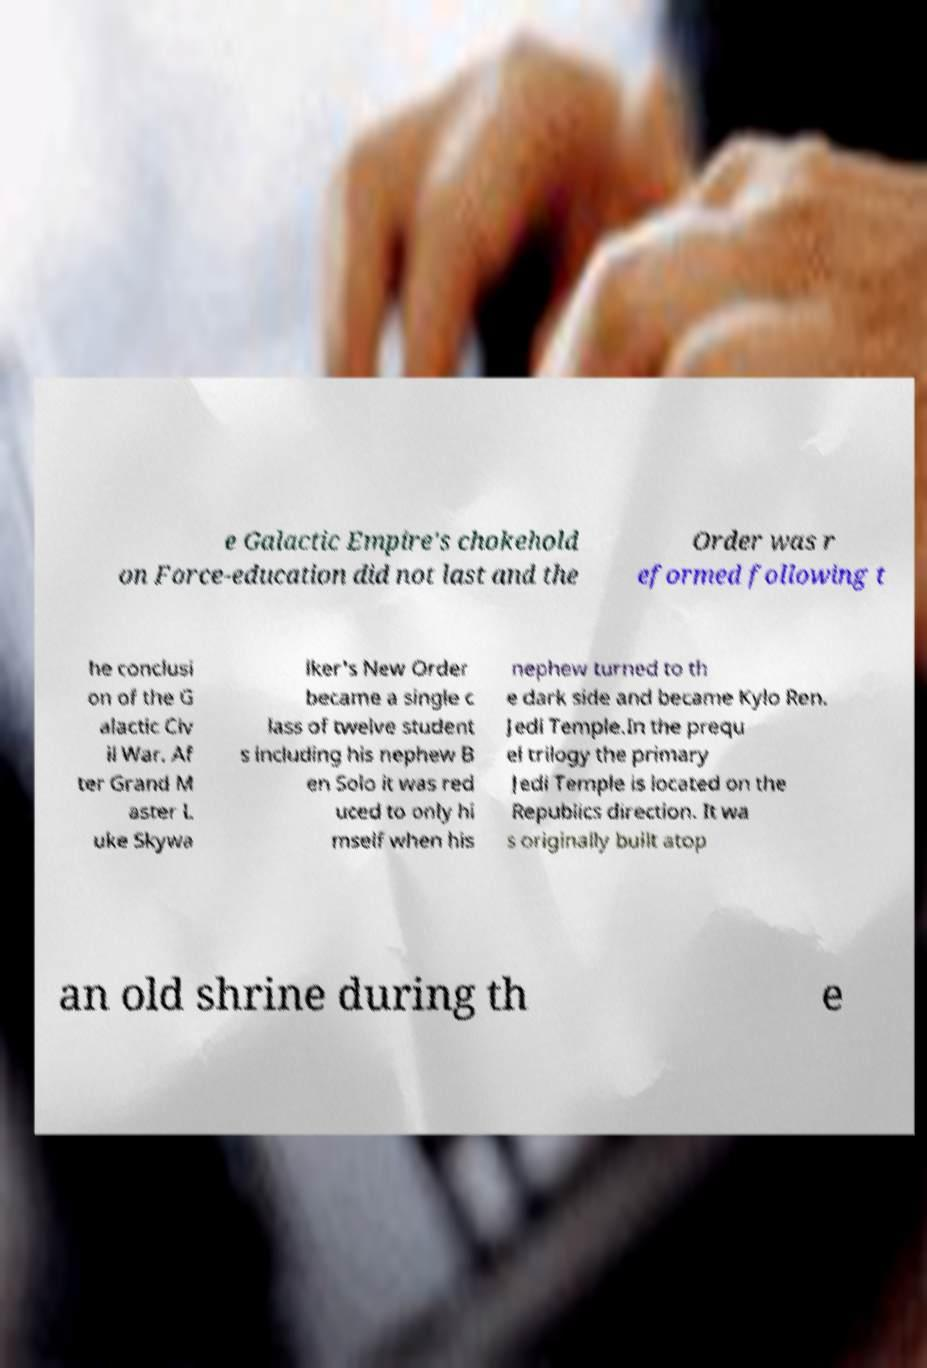I need the written content from this picture converted into text. Can you do that? e Galactic Empire's chokehold on Force-education did not last and the Order was r eformed following t he conclusi on of the G alactic Civ il War. Af ter Grand M aster L uke Skywa lker's New Order became a single c lass of twelve student s including his nephew B en Solo it was red uced to only hi mself when his nephew turned to th e dark side and became Kylo Ren. Jedi Temple.In the prequ el trilogy the primary Jedi Temple is located on the Republics direction. It wa s originally built atop an old shrine during th e 